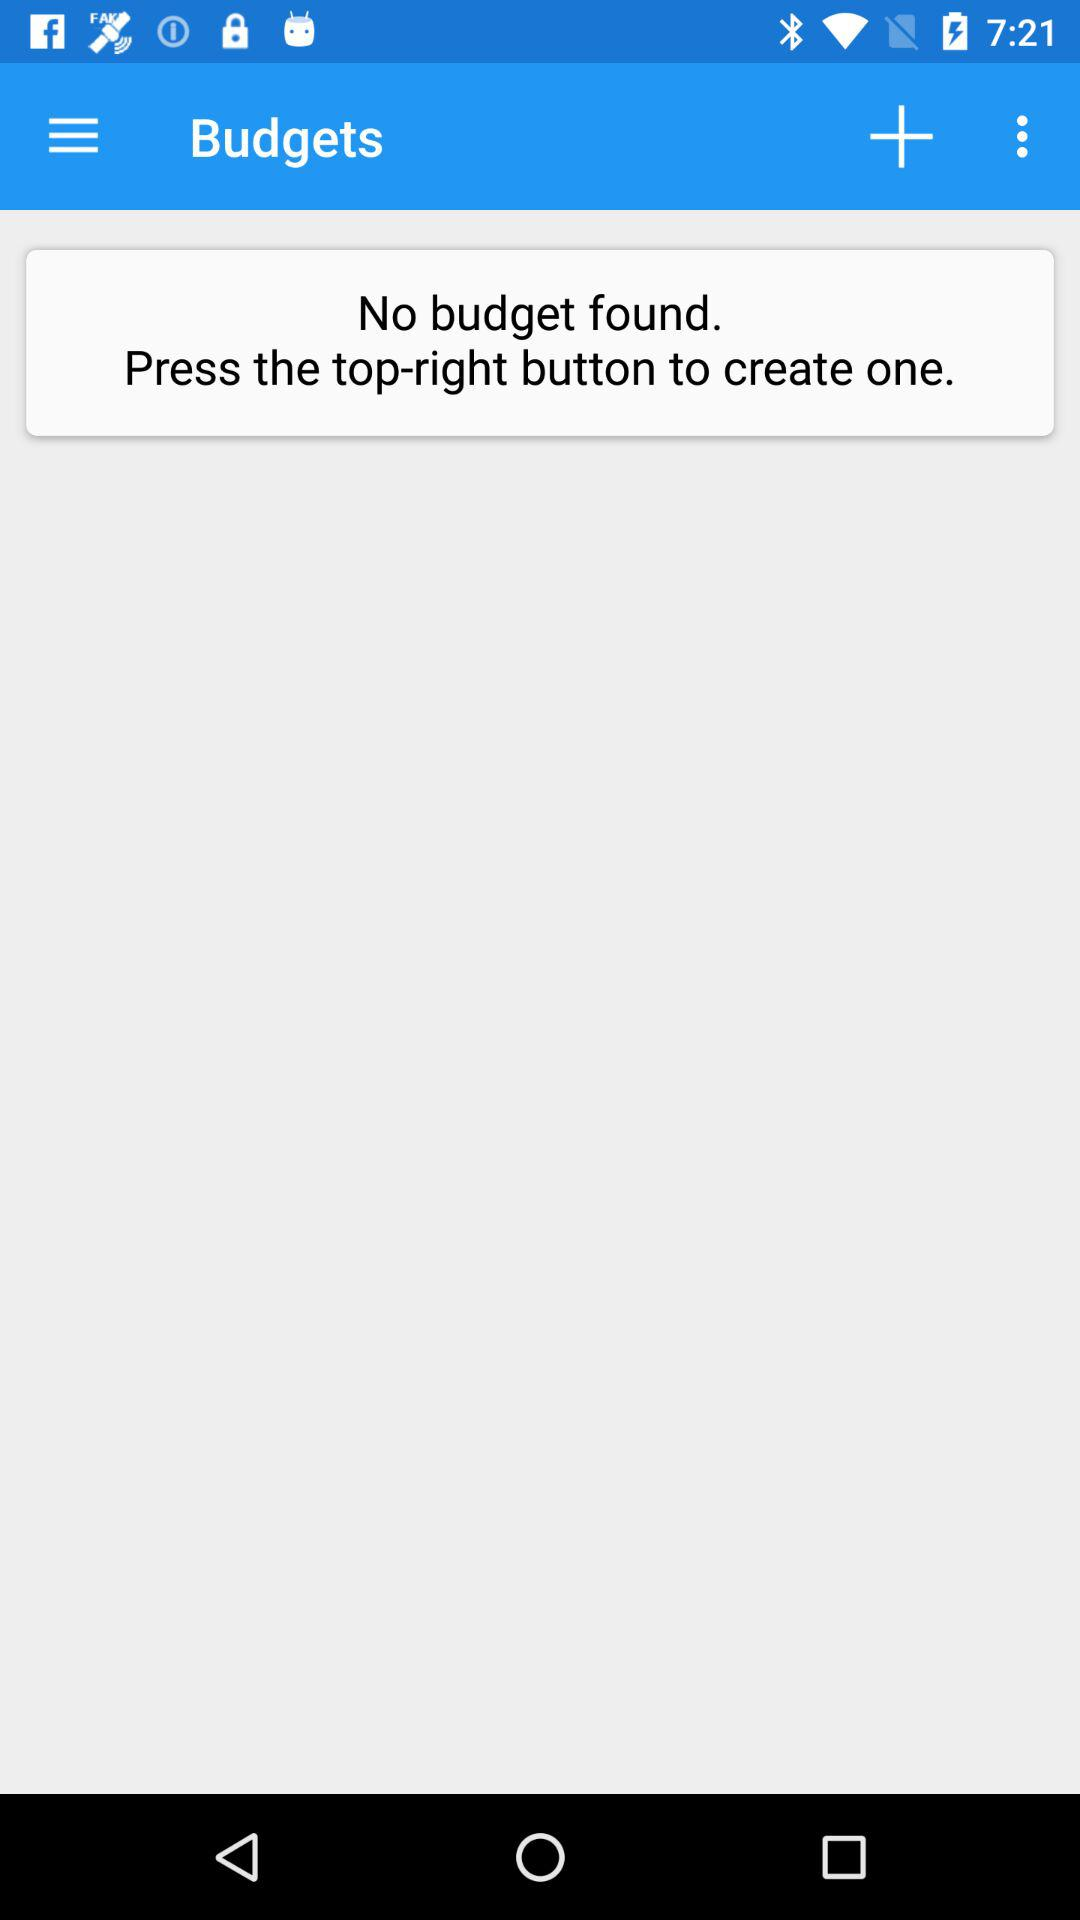Is there any budget found? There is no budget found. 